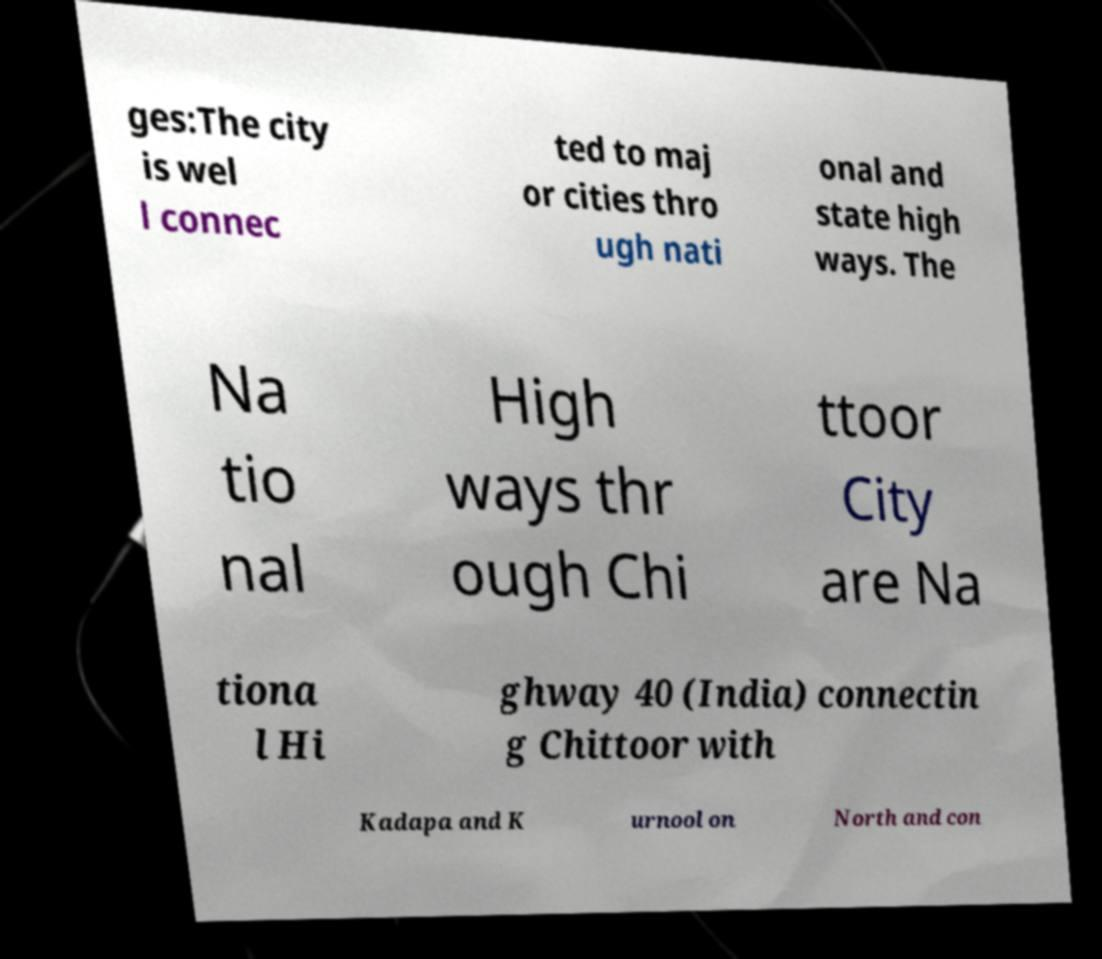What messages or text are displayed in this image? I need them in a readable, typed format. ges:The city is wel l connec ted to maj or cities thro ugh nati onal and state high ways. The Na tio nal High ways thr ough Chi ttoor City are Na tiona l Hi ghway 40 (India) connectin g Chittoor with Kadapa and K urnool on North and con 